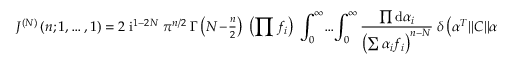<formula> <loc_0><loc_0><loc_500><loc_500>J ^ { ( N ) } \left ( n ; 1 , \dots , 1 \right ) = 2 \, i ^ { 1 - 2 N } \, \pi ^ { n / 2 } \, \Gamma \left ( N \, - \, { \frac { n } { 2 } } \right ) \, \left ( \prod f _ { i } \right ) \, \int _ { 0 } ^ { \infty } \, \dots \, \int _ { 0 } ^ { \infty } \frac { \prod d \alpha _ { i } } { \left ( \sum \alpha _ { i } f _ { i } \right ) ^ { n - N } } \, \delta \left ( \alpha ^ { T } \| C \| \alpha - 1 \right ) .</formula> 